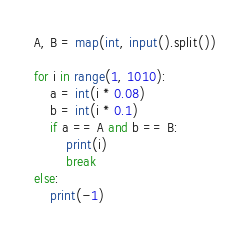Convert code to text. <code><loc_0><loc_0><loc_500><loc_500><_Python_>A, B = map(int, input().split())

for i in range(1, 1010):
    a = int(i * 0.08)
    b = int(i * 0.1)
    if a == A and b == B:
        print(i)
        break
else:
    print(-1)</code> 